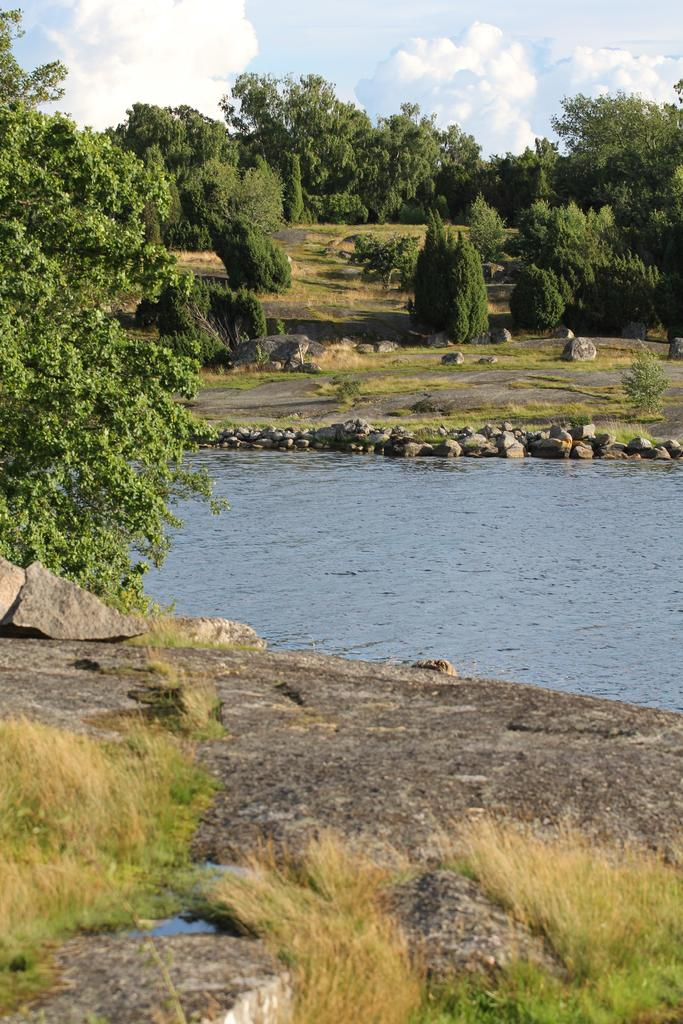What type of vegetation can be seen in the image? There is grass in the image. What other objects can be seen in the image? There are stones and a tree visible in the image. What natural element is visible in the image? There is water visible in the image. What can be seen in the background of the image? There is grass, trees, and the sky visible in the background of the image. What type of grape can be seen growing on the tree in the image? There are no grapes present in the image; the tree is not a grape vine. What is the boundary of the grassy area in the image? There is no specific boundary identified in the image; it is not clearly defined. 